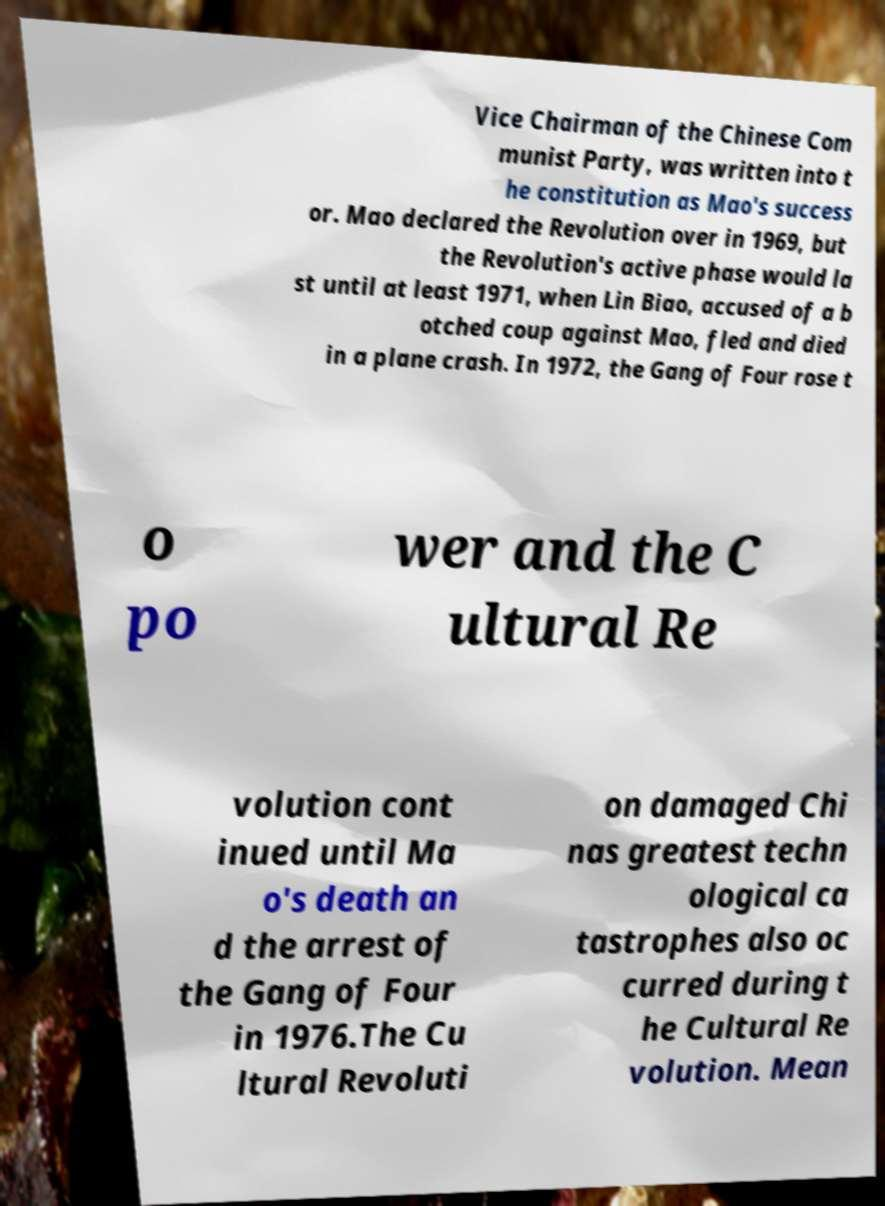I need the written content from this picture converted into text. Can you do that? Vice Chairman of the Chinese Com munist Party, was written into t he constitution as Mao's success or. Mao declared the Revolution over in 1969, but the Revolution's active phase would la st until at least 1971, when Lin Biao, accused of a b otched coup against Mao, fled and died in a plane crash. In 1972, the Gang of Four rose t o po wer and the C ultural Re volution cont inued until Ma o's death an d the arrest of the Gang of Four in 1976.The Cu ltural Revoluti on damaged Chi nas greatest techn ological ca tastrophes also oc curred during t he Cultural Re volution. Mean 